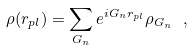<formula> <loc_0><loc_0><loc_500><loc_500>\rho ( { r } _ { p l } ) = \sum _ { G _ { n } } e ^ { i { G } _ { n } { r } _ { p l } } \rho _ { { G } _ { n } } \ ,</formula> 